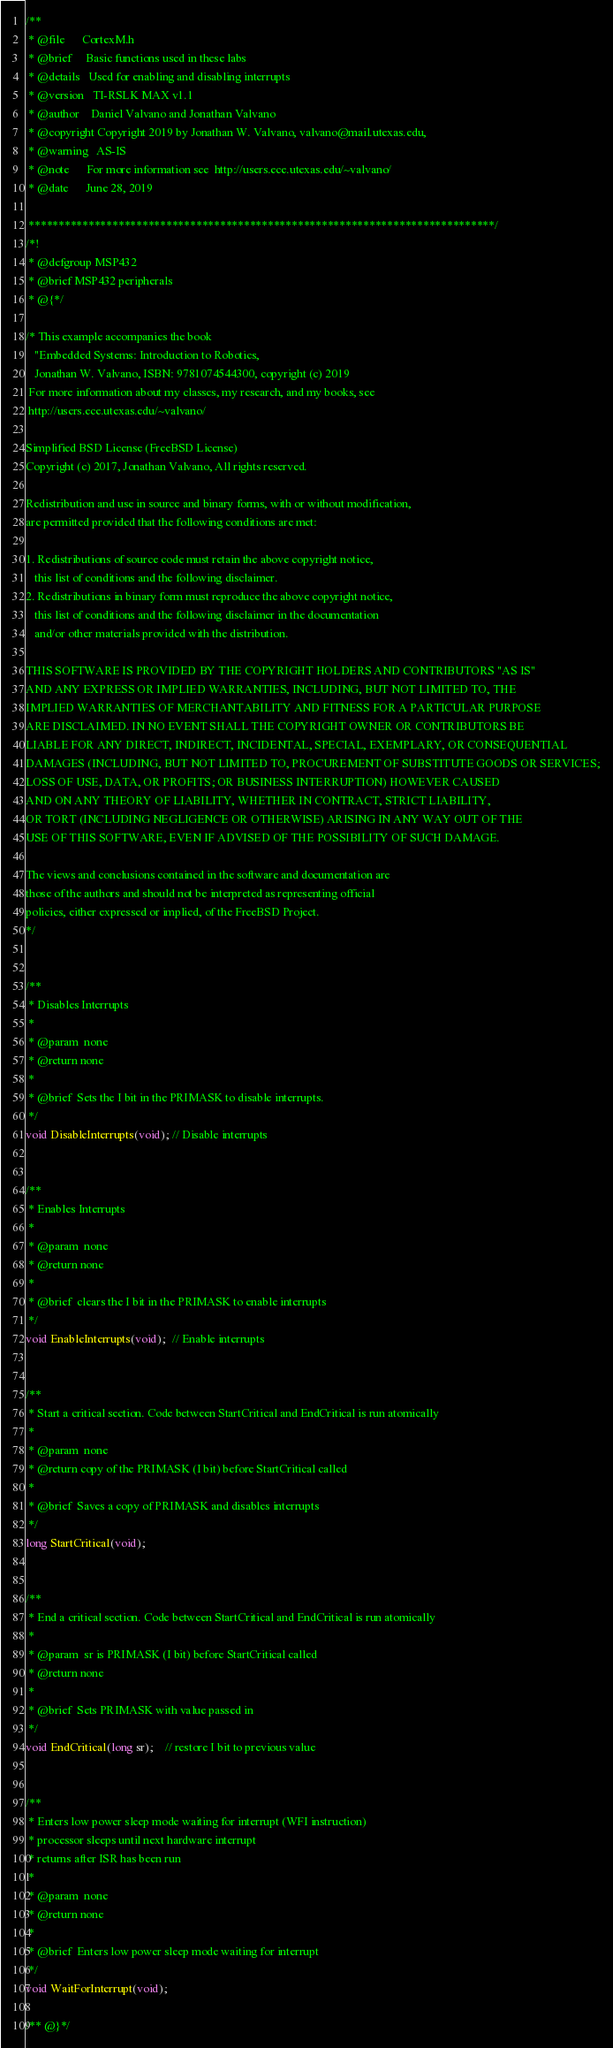Convert code to text. <code><loc_0><loc_0><loc_500><loc_500><_C_>/**
 * @file      CortexM.h
 * @brief     Basic functions used in these labs
 * @details   Used for enabling and disabling interrupts
 * @version   TI-RSLK MAX v1.1
 * @author    Daniel Valvano and Jonathan Valvano
 * @copyright Copyright 2019 by Jonathan W. Valvano, valvano@mail.utexas.edu,
 * @warning   AS-IS
 * @note      For more information see  http://users.ece.utexas.edu/~valvano/
 * @date      June 28, 2019

 ******************************************************************************/
/*!
 * @defgroup MSP432
 * @brief MSP432 peripherals
 * @{*/

/* This example accompanies the book
   "Embedded Systems: Introduction to Robotics,
   Jonathan W. Valvano, ISBN: 9781074544300, copyright (c) 2019
 For more information about my classes, my research, and my books, see
 http://users.ece.utexas.edu/~valvano/

Simplified BSD License (FreeBSD License)
Copyright (c) 2017, Jonathan Valvano, All rights reserved.

Redistribution and use in source and binary forms, with or without modification,
are permitted provided that the following conditions are met:

1. Redistributions of source code must retain the above copyright notice,
   this list of conditions and the following disclaimer.
2. Redistributions in binary form must reproduce the above copyright notice,
   this list of conditions and the following disclaimer in the documentation
   and/or other materials provided with the distribution.

THIS SOFTWARE IS PROVIDED BY THE COPYRIGHT HOLDERS AND CONTRIBUTORS "AS IS"
AND ANY EXPRESS OR IMPLIED WARRANTIES, INCLUDING, BUT NOT LIMITED TO, THE
IMPLIED WARRANTIES OF MERCHANTABILITY AND FITNESS FOR A PARTICULAR PURPOSE
ARE DISCLAIMED. IN NO EVENT SHALL THE COPYRIGHT OWNER OR CONTRIBUTORS BE
LIABLE FOR ANY DIRECT, INDIRECT, INCIDENTAL, SPECIAL, EXEMPLARY, OR CONSEQUENTIAL
DAMAGES (INCLUDING, BUT NOT LIMITED TO, PROCUREMENT OF SUBSTITUTE GOODS OR SERVICES;
LOSS OF USE, DATA, OR PROFITS; OR BUSINESS INTERRUPTION) HOWEVER CAUSED
AND ON ANY THEORY OF LIABILITY, WHETHER IN CONTRACT, STRICT LIABILITY,
OR TORT (INCLUDING NEGLIGENCE OR OTHERWISE) ARISING IN ANY WAY OUT OF THE
USE OF THIS SOFTWARE, EVEN IF ADVISED OF THE POSSIBILITY OF SUCH DAMAGE.

The views and conclusions contained in the software and documentation are
those of the authors and should not be interpreted as representing official
policies, either expressed or implied, of the FreeBSD Project.
*/


/**
 * Disables Interrupts
 *
 * @param  none
 * @return none
 *
 * @brief  Sets the I bit in the PRIMASK to disable interrupts.
 */
void DisableInterrupts(void); // Disable interrupts


/**
 * Enables Interrupts
 *
 * @param  none
 * @return none
 *
 * @brief  clears the I bit in the PRIMASK to enable interrupts
 */
void EnableInterrupts(void);  // Enable interrupts


/**
 * Start a critical section. Code between StartCritical and EndCritical is run atomically
 *
 * @param  none
 * @return copy of the PRIMASK (I bit) before StartCritical called
 *
 * @brief  Saves a copy of PRIMASK and disables interrupts
 */
long StartCritical(void);    


/**
 * End a critical section. Code between StartCritical and EndCritical is run atomically
 *
 * @param  sr is PRIMASK (I bit) before StartCritical called
 * @return none
 *
 * @brief  Sets PRIMASK with value passed in
 */
void EndCritical(long sr);    // restore I bit to previous value


/**
 * Enters low power sleep mode waiting for interrupt (WFI instruction)
 * processor sleeps until next hardware interrupt
 * returns after ISR has been run
 *
 * @param  none
 * @return none
 *
 * @brief  Enters low power sleep mode waiting for interrupt
 */
void WaitForInterrupt(void);  

/** @}*/
</code> 